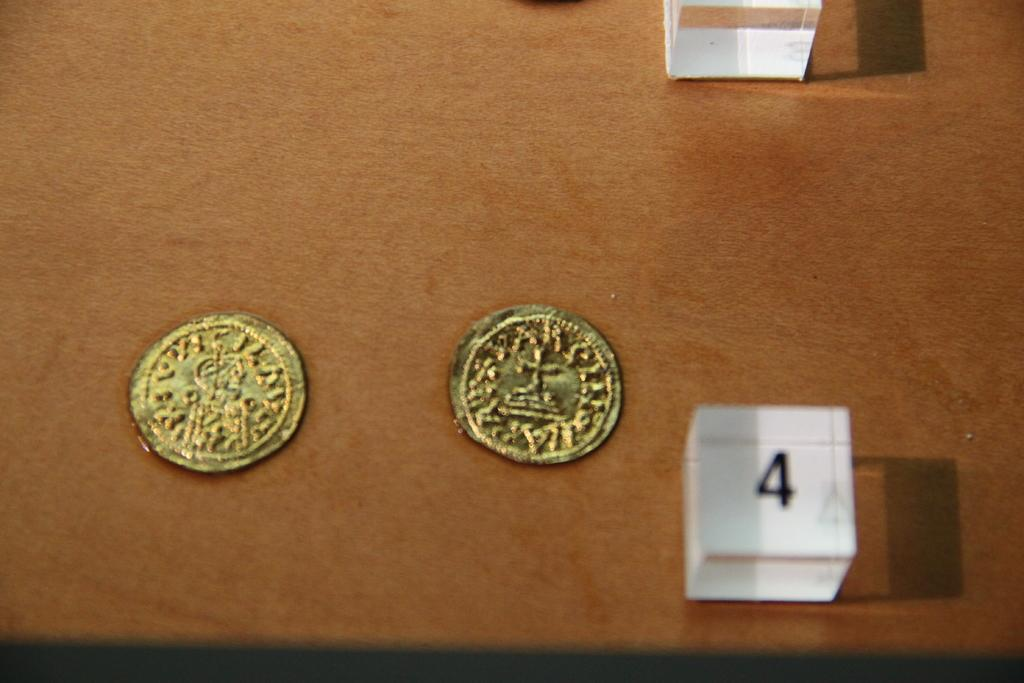Provide a one-sentence caption for the provided image. two old gold coins on a wooden table with a number four in a cube. 